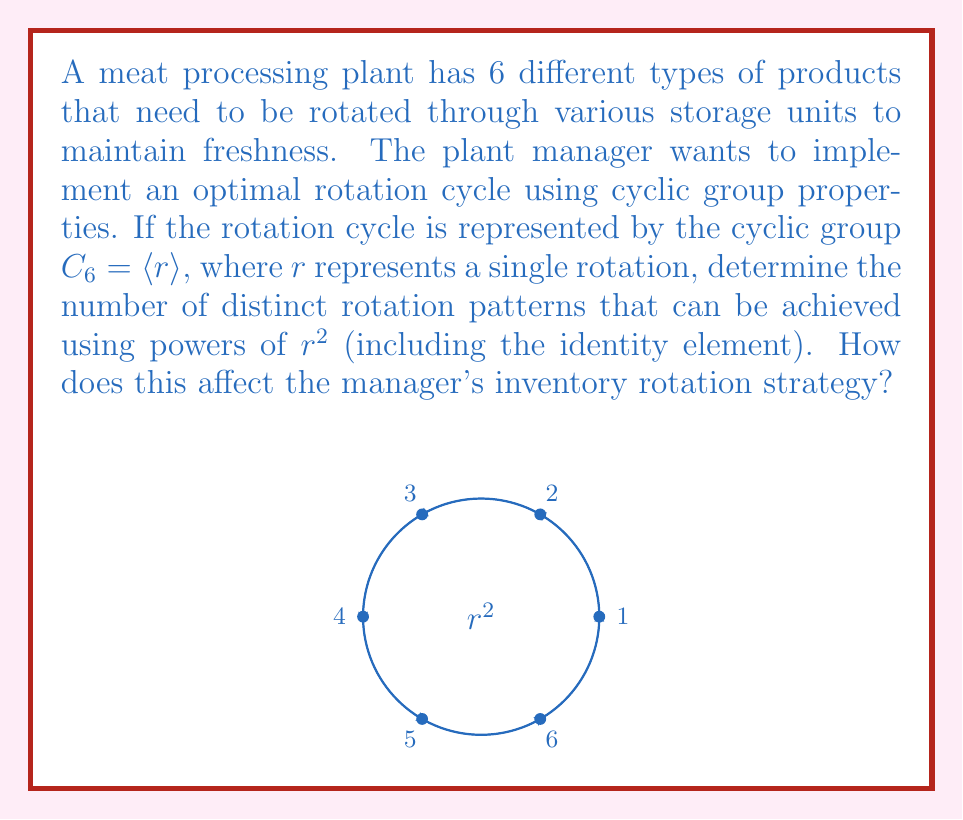Solve this math problem. Let's approach this step-by-step:

1) In the cyclic group $C_6 = \langle r \rangle$, we have:
   $C_6 = \{e, r, r^2, r^3, r^4, r^5\}$, where $e$ is the identity element and $r^6 = e$.

2) We're interested in the subgroup generated by $r^2$. Let's compute the powers of $r^2$:
   $(r^2)^1 = r^2$
   $(r^2)^2 = r^4$
   $(r^2)^3 = r^6 = e$

3) This forms a subgroup $H = \{e, r^2, r^4\}$ of $C_6$.

4) The order of this subgroup is 3, which means there are 3 distinct rotation patterns using powers of $r^2$.

5) In the context of the meat processing plant:
   - $e$ represents no rotation (identity)
   - $r^2$ represents rotating the products by 2 positions
   - $r^4$ represents rotating the products by 4 positions

6) This affects the manager's inventory rotation strategy in the following ways:
   - The rotation cycle repeats every 3 steps instead of 6.
   - Products will only occupy even-numbered positions in the cycle.
   - This creates two separate cycles: (1,3,5) and (2,4,6), which don't interact.

7) While this simplifies the rotation process, it may not be optimal for all products, as some positions are skipped in each subcycle.
Answer: 3 distinct rotation patterns; creates two separate subcycles (1,3,5) and (2,4,6). 